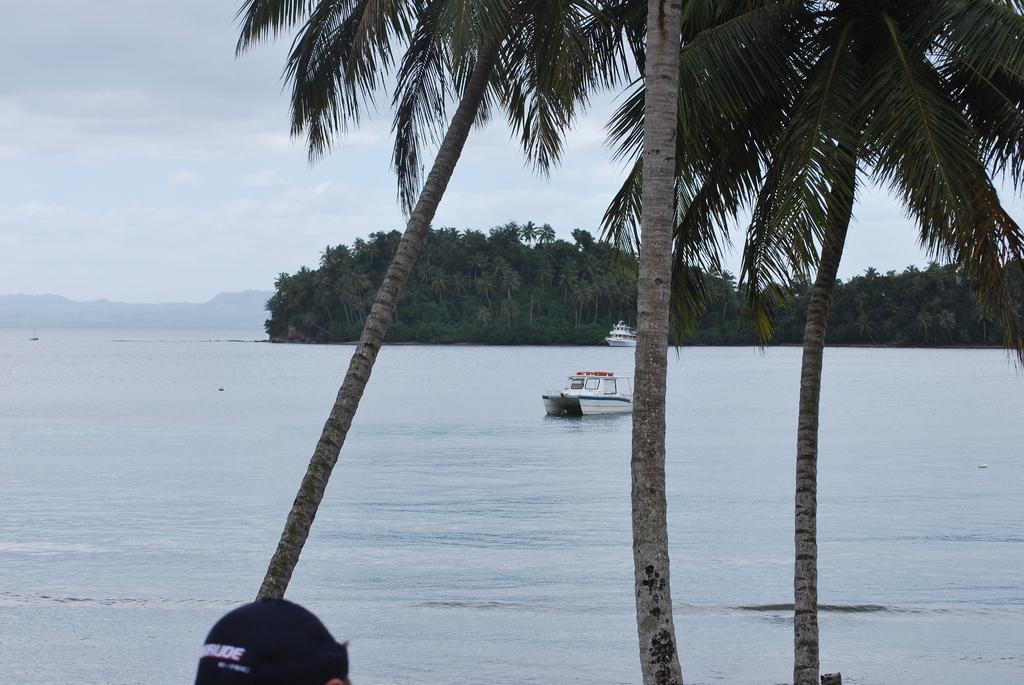How would you summarize this image in a sentence or two? In this image we can see two boats on the water and there are some trees and we can see a person's head at the bottom of the image. we can see the mountains in the background and at the top we can see the sky. 